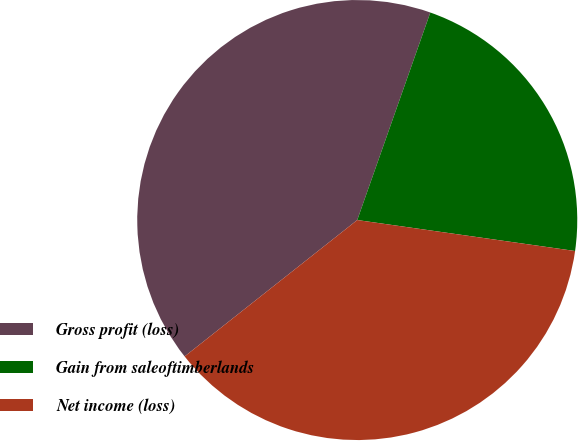Convert chart to OTSL. <chart><loc_0><loc_0><loc_500><loc_500><pie_chart><fcel>Gross profit (loss)<fcel>Gain from saleoftimberlands<fcel>Net income (loss)<nl><fcel>41.03%<fcel>21.86%<fcel>37.11%<nl></chart> 